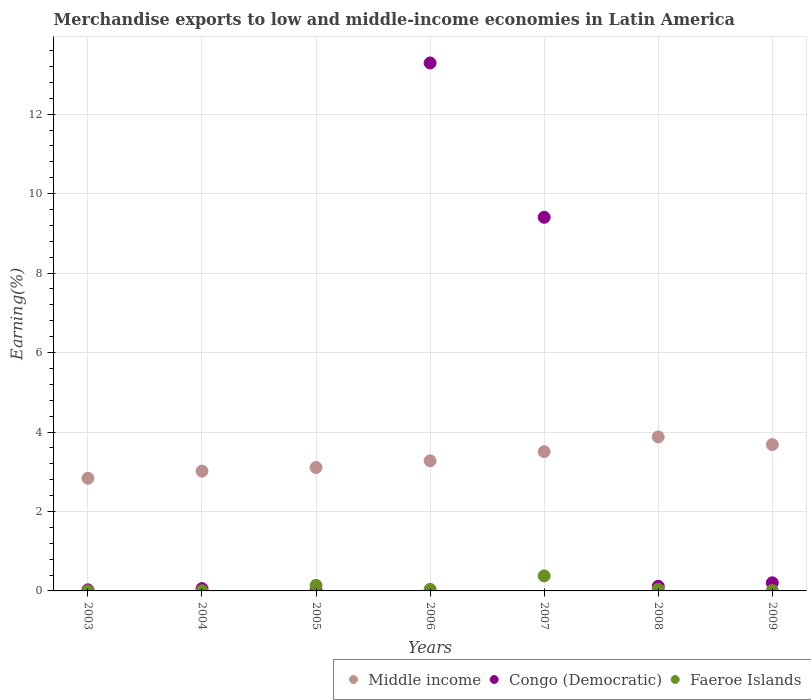How many different coloured dotlines are there?
Your response must be concise. 3. Is the number of dotlines equal to the number of legend labels?
Your answer should be very brief. Yes. What is the percentage of amount earned from merchandise exports in Middle income in 2004?
Provide a short and direct response. 3.02. Across all years, what is the maximum percentage of amount earned from merchandise exports in Middle income?
Provide a short and direct response. 3.88. Across all years, what is the minimum percentage of amount earned from merchandise exports in Congo (Democratic)?
Offer a terse response. 0.02. In which year was the percentage of amount earned from merchandise exports in Congo (Democratic) minimum?
Ensure brevity in your answer.  2005. What is the total percentage of amount earned from merchandise exports in Middle income in the graph?
Your answer should be very brief. 23.3. What is the difference between the percentage of amount earned from merchandise exports in Congo (Democratic) in 2005 and that in 2007?
Ensure brevity in your answer.  -9.39. What is the difference between the percentage of amount earned from merchandise exports in Congo (Democratic) in 2005 and the percentage of amount earned from merchandise exports in Middle income in 2007?
Offer a terse response. -3.49. What is the average percentage of amount earned from merchandise exports in Faeroe Islands per year?
Provide a short and direct response. 0.09. In the year 2004, what is the difference between the percentage of amount earned from merchandise exports in Faeroe Islands and percentage of amount earned from merchandise exports in Middle income?
Give a very brief answer. -3.01. What is the ratio of the percentage of amount earned from merchandise exports in Faeroe Islands in 2005 to that in 2007?
Your answer should be compact. 0.37. What is the difference between the highest and the second highest percentage of amount earned from merchandise exports in Faeroe Islands?
Give a very brief answer. 0.24. What is the difference between the highest and the lowest percentage of amount earned from merchandise exports in Middle income?
Provide a short and direct response. 1.04. In how many years, is the percentage of amount earned from merchandise exports in Middle income greater than the average percentage of amount earned from merchandise exports in Middle income taken over all years?
Offer a very short reply. 3. Is the sum of the percentage of amount earned from merchandise exports in Middle income in 2004 and 2009 greater than the maximum percentage of amount earned from merchandise exports in Congo (Democratic) across all years?
Your answer should be compact. No. Is it the case that in every year, the sum of the percentage of amount earned from merchandise exports in Middle income and percentage of amount earned from merchandise exports in Congo (Democratic)  is greater than the percentage of amount earned from merchandise exports in Faeroe Islands?
Provide a succinct answer. Yes. Is the percentage of amount earned from merchandise exports in Congo (Democratic) strictly less than the percentage of amount earned from merchandise exports in Middle income over the years?
Offer a terse response. No. What is the difference between two consecutive major ticks on the Y-axis?
Give a very brief answer. 2. What is the title of the graph?
Your answer should be compact. Merchandise exports to low and middle-income economies in Latin America. What is the label or title of the Y-axis?
Provide a succinct answer. Earning(%). What is the Earning(%) of Middle income in 2003?
Provide a short and direct response. 2.84. What is the Earning(%) in Congo (Democratic) in 2003?
Provide a short and direct response. 0.03. What is the Earning(%) in Faeroe Islands in 2003?
Make the answer very short. 0. What is the Earning(%) of Middle income in 2004?
Your answer should be compact. 3.02. What is the Earning(%) of Congo (Democratic) in 2004?
Ensure brevity in your answer.  0.06. What is the Earning(%) of Faeroe Islands in 2004?
Give a very brief answer. 0. What is the Earning(%) of Middle income in 2005?
Provide a short and direct response. 3.11. What is the Earning(%) of Congo (Democratic) in 2005?
Ensure brevity in your answer.  0.02. What is the Earning(%) of Faeroe Islands in 2005?
Your answer should be compact. 0.14. What is the Earning(%) in Middle income in 2006?
Give a very brief answer. 3.27. What is the Earning(%) in Congo (Democratic) in 2006?
Make the answer very short. 13.29. What is the Earning(%) of Faeroe Islands in 2006?
Keep it short and to the point. 0.04. What is the Earning(%) of Middle income in 2007?
Offer a terse response. 3.5. What is the Earning(%) of Congo (Democratic) in 2007?
Provide a succinct answer. 9.4. What is the Earning(%) in Faeroe Islands in 2007?
Make the answer very short. 0.38. What is the Earning(%) in Middle income in 2008?
Keep it short and to the point. 3.88. What is the Earning(%) of Congo (Democratic) in 2008?
Your answer should be very brief. 0.12. What is the Earning(%) in Faeroe Islands in 2008?
Provide a short and direct response. 0.04. What is the Earning(%) of Middle income in 2009?
Your answer should be compact. 3.68. What is the Earning(%) in Congo (Democratic) in 2009?
Your answer should be very brief. 0.2. What is the Earning(%) of Faeroe Islands in 2009?
Your response must be concise. 0.01. Across all years, what is the maximum Earning(%) in Middle income?
Provide a short and direct response. 3.88. Across all years, what is the maximum Earning(%) of Congo (Democratic)?
Your response must be concise. 13.29. Across all years, what is the maximum Earning(%) of Faeroe Islands?
Make the answer very short. 0.38. Across all years, what is the minimum Earning(%) in Middle income?
Ensure brevity in your answer.  2.84. Across all years, what is the minimum Earning(%) of Congo (Democratic)?
Keep it short and to the point. 0.02. Across all years, what is the minimum Earning(%) in Faeroe Islands?
Your answer should be very brief. 0. What is the total Earning(%) in Middle income in the graph?
Your response must be concise. 23.3. What is the total Earning(%) in Congo (Democratic) in the graph?
Provide a short and direct response. 23.12. What is the total Earning(%) of Faeroe Islands in the graph?
Give a very brief answer. 0.62. What is the difference between the Earning(%) of Middle income in 2003 and that in 2004?
Make the answer very short. -0.18. What is the difference between the Earning(%) in Congo (Democratic) in 2003 and that in 2004?
Offer a terse response. -0.03. What is the difference between the Earning(%) of Faeroe Islands in 2003 and that in 2004?
Offer a terse response. -0. What is the difference between the Earning(%) in Middle income in 2003 and that in 2005?
Provide a succinct answer. -0.27. What is the difference between the Earning(%) of Congo (Democratic) in 2003 and that in 2005?
Offer a very short reply. 0.01. What is the difference between the Earning(%) in Faeroe Islands in 2003 and that in 2005?
Ensure brevity in your answer.  -0.14. What is the difference between the Earning(%) in Middle income in 2003 and that in 2006?
Provide a short and direct response. -0.44. What is the difference between the Earning(%) of Congo (Democratic) in 2003 and that in 2006?
Keep it short and to the point. -13.26. What is the difference between the Earning(%) of Faeroe Islands in 2003 and that in 2006?
Your answer should be compact. -0.03. What is the difference between the Earning(%) in Middle income in 2003 and that in 2007?
Provide a succinct answer. -0.67. What is the difference between the Earning(%) of Congo (Democratic) in 2003 and that in 2007?
Your answer should be very brief. -9.38. What is the difference between the Earning(%) of Faeroe Islands in 2003 and that in 2007?
Your response must be concise. -0.38. What is the difference between the Earning(%) of Middle income in 2003 and that in 2008?
Make the answer very short. -1.04. What is the difference between the Earning(%) of Congo (Democratic) in 2003 and that in 2008?
Keep it short and to the point. -0.09. What is the difference between the Earning(%) of Faeroe Islands in 2003 and that in 2008?
Provide a succinct answer. -0.04. What is the difference between the Earning(%) in Middle income in 2003 and that in 2009?
Make the answer very short. -0.85. What is the difference between the Earning(%) in Congo (Democratic) in 2003 and that in 2009?
Offer a very short reply. -0.18. What is the difference between the Earning(%) in Faeroe Islands in 2003 and that in 2009?
Offer a very short reply. -0.01. What is the difference between the Earning(%) of Middle income in 2004 and that in 2005?
Keep it short and to the point. -0.09. What is the difference between the Earning(%) of Congo (Democratic) in 2004 and that in 2005?
Provide a short and direct response. 0.04. What is the difference between the Earning(%) of Faeroe Islands in 2004 and that in 2005?
Offer a terse response. -0.14. What is the difference between the Earning(%) of Middle income in 2004 and that in 2006?
Your answer should be compact. -0.26. What is the difference between the Earning(%) in Congo (Democratic) in 2004 and that in 2006?
Make the answer very short. -13.23. What is the difference between the Earning(%) of Faeroe Islands in 2004 and that in 2006?
Give a very brief answer. -0.03. What is the difference between the Earning(%) of Middle income in 2004 and that in 2007?
Your answer should be very brief. -0.49. What is the difference between the Earning(%) of Congo (Democratic) in 2004 and that in 2007?
Keep it short and to the point. -9.35. What is the difference between the Earning(%) in Faeroe Islands in 2004 and that in 2007?
Keep it short and to the point. -0.37. What is the difference between the Earning(%) in Middle income in 2004 and that in 2008?
Make the answer very short. -0.86. What is the difference between the Earning(%) of Congo (Democratic) in 2004 and that in 2008?
Give a very brief answer. -0.06. What is the difference between the Earning(%) in Faeroe Islands in 2004 and that in 2008?
Keep it short and to the point. -0.04. What is the difference between the Earning(%) of Middle income in 2004 and that in 2009?
Your response must be concise. -0.67. What is the difference between the Earning(%) of Congo (Democratic) in 2004 and that in 2009?
Make the answer very short. -0.15. What is the difference between the Earning(%) of Faeroe Islands in 2004 and that in 2009?
Make the answer very short. -0.01. What is the difference between the Earning(%) in Middle income in 2005 and that in 2006?
Your answer should be compact. -0.17. What is the difference between the Earning(%) in Congo (Democratic) in 2005 and that in 2006?
Provide a succinct answer. -13.27. What is the difference between the Earning(%) in Faeroe Islands in 2005 and that in 2006?
Your answer should be compact. 0.1. What is the difference between the Earning(%) in Middle income in 2005 and that in 2007?
Offer a terse response. -0.4. What is the difference between the Earning(%) of Congo (Democratic) in 2005 and that in 2007?
Offer a very short reply. -9.39. What is the difference between the Earning(%) in Faeroe Islands in 2005 and that in 2007?
Give a very brief answer. -0.24. What is the difference between the Earning(%) in Middle income in 2005 and that in 2008?
Ensure brevity in your answer.  -0.77. What is the difference between the Earning(%) in Congo (Democratic) in 2005 and that in 2008?
Offer a very short reply. -0.1. What is the difference between the Earning(%) in Faeroe Islands in 2005 and that in 2008?
Offer a terse response. 0.1. What is the difference between the Earning(%) in Middle income in 2005 and that in 2009?
Your response must be concise. -0.58. What is the difference between the Earning(%) in Congo (Democratic) in 2005 and that in 2009?
Ensure brevity in your answer.  -0.19. What is the difference between the Earning(%) in Faeroe Islands in 2005 and that in 2009?
Provide a succinct answer. 0.13. What is the difference between the Earning(%) in Middle income in 2006 and that in 2007?
Provide a succinct answer. -0.23. What is the difference between the Earning(%) in Congo (Democratic) in 2006 and that in 2007?
Make the answer very short. 3.88. What is the difference between the Earning(%) in Faeroe Islands in 2006 and that in 2007?
Offer a terse response. -0.34. What is the difference between the Earning(%) of Middle income in 2006 and that in 2008?
Provide a succinct answer. -0.6. What is the difference between the Earning(%) of Congo (Democratic) in 2006 and that in 2008?
Offer a terse response. 13.17. What is the difference between the Earning(%) of Faeroe Islands in 2006 and that in 2008?
Offer a terse response. -0. What is the difference between the Earning(%) in Middle income in 2006 and that in 2009?
Provide a short and direct response. -0.41. What is the difference between the Earning(%) in Congo (Democratic) in 2006 and that in 2009?
Keep it short and to the point. 13.08. What is the difference between the Earning(%) in Faeroe Islands in 2006 and that in 2009?
Ensure brevity in your answer.  0.03. What is the difference between the Earning(%) in Middle income in 2007 and that in 2008?
Offer a terse response. -0.37. What is the difference between the Earning(%) of Congo (Democratic) in 2007 and that in 2008?
Ensure brevity in your answer.  9.29. What is the difference between the Earning(%) of Faeroe Islands in 2007 and that in 2008?
Your answer should be very brief. 0.34. What is the difference between the Earning(%) in Middle income in 2007 and that in 2009?
Offer a terse response. -0.18. What is the difference between the Earning(%) in Congo (Democratic) in 2007 and that in 2009?
Offer a terse response. 9.2. What is the difference between the Earning(%) of Faeroe Islands in 2007 and that in 2009?
Your response must be concise. 0.37. What is the difference between the Earning(%) in Middle income in 2008 and that in 2009?
Give a very brief answer. 0.19. What is the difference between the Earning(%) of Congo (Democratic) in 2008 and that in 2009?
Offer a very short reply. -0.09. What is the difference between the Earning(%) of Faeroe Islands in 2008 and that in 2009?
Offer a very short reply. 0.03. What is the difference between the Earning(%) in Middle income in 2003 and the Earning(%) in Congo (Democratic) in 2004?
Ensure brevity in your answer.  2.78. What is the difference between the Earning(%) of Middle income in 2003 and the Earning(%) of Faeroe Islands in 2004?
Offer a very short reply. 2.83. What is the difference between the Earning(%) of Congo (Democratic) in 2003 and the Earning(%) of Faeroe Islands in 2004?
Offer a very short reply. 0.02. What is the difference between the Earning(%) of Middle income in 2003 and the Earning(%) of Congo (Democratic) in 2005?
Keep it short and to the point. 2.82. What is the difference between the Earning(%) in Middle income in 2003 and the Earning(%) in Faeroe Islands in 2005?
Make the answer very short. 2.7. What is the difference between the Earning(%) in Congo (Democratic) in 2003 and the Earning(%) in Faeroe Islands in 2005?
Your answer should be compact. -0.11. What is the difference between the Earning(%) of Middle income in 2003 and the Earning(%) of Congo (Democratic) in 2006?
Your response must be concise. -10.45. What is the difference between the Earning(%) of Middle income in 2003 and the Earning(%) of Faeroe Islands in 2006?
Offer a very short reply. 2.8. What is the difference between the Earning(%) of Congo (Democratic) in 2003 and the Earning(%) of Faeroe Islands in 2006?
Make the answer very short. -0.01. What is the difference between the Earning(%) of Middle income in 2003 and the Earning(%) of Congo (Democratic) in 2007?
Your answer should be compact. -6.57. What is the difference between the Earning(%) of Middle income in 2003 and the Earning(%) of Faeroe Islands in 2007?
Your answer should be compact. 2.46. What is the difference between the Earning(%) of Congo (Democratic) in 2003 and the Earning(%) of Faeroe Islands in 2007?
Provide a succinct answer. -0.35. What is the difference between the Earning(%) of Middle income in 2003 and the Earning(%) of Congo (Democratic) in 2008?
Make the answer very short. 2.72. What is the difference between the Earning(%) of Middle income in 2003 and the Earning(%) of Faeroe Islands in 2008?
Provide a succinct answer. 2.79. What is the difference between the Earning(%) in Congo (Democratic) in 2003 and the Earning(%) in Faeroe Islands in 2008?
Your response must be concise. -0.02. What is the difference between the Earning(%) in Middle income in 2003 and the Earning(%) in Congo (Democratic) in 2009?
Offer a terse response. 2.63. What is the difference between the Earning(%) of Middle income in 2003 and the Earning(%) of Faeroe Islands in 2009?
Provide a short and direct response. 2.83. What is the difference between the Earning(%) of Congo (Democratic) in 2003 and the Earning(%) of Faeroe Islands in 2009?
Offer a very short reply. 0.02. What is the difference between the Earning(%) in Middle income in 2004 and the Earning(%) in Congo (Democratic) in 2005?
Offer a terse response. 3. What is the difference between the Earning(%) of Middle income in 2004 and the Earning(%) of Faeroe Islands in 2005?
Provide a succinct answer. 2.88. What is the difference between the Earning(%) of Congo (Democratic) in 2004 and the Earning(%) of Faeroe Islands in 2005?
Offer a terse response. -0.08. What is the difference between the Earning(%) of Middle income in 2004 and the Earning(%) of Congo (Democratic) in 2006?
Your response must be concise. -10.27. What is the difference between the Earning(%) in Middle income in 2004 and the Earning(%) in Faeroe Islands in 2006?
Offer a terse response. 2.98. What is the difference between the Earning(%) of Congo (Democratic) in 2004 and the Earning(%) of Faeroe Islands in 2006?
Offer a very short reply. 0.02. What is the difference between the Earning(%) in Middle income in 2004 and the Earning(%) in Congo (Democratic) in 2007?
Give a very brief answer. -6.39. What is the difference between the Earning(%) in Middle income in 2004 and the Earning(%) in Faeroe Islands in 2007?
Keep it short and to the point. 2.64. What is the difference between the Earning(%) in Congo (Democratic) in 2004 and the Earning(%) in Faeroe Islands in 2007?
Keep it short and to the point. -0.32. What is the difference between the Earning(%) in Middle income in 2004 and the Earning(%) in Congo (Democratic) in 2008?
Provide a succinct answer. 2.9. What is the difference between the Earning(%) of Middle income in 2004 and the Earning(%) of Faeroe Islands in 2008?
Offer a terse response. 2.97. What is the difference between the Earning(%) in Congo (Democratic) in 2004 and the Earning(%) in Faeroe Islands in 2008?
Give a very brief answer. 0.02. What is the difference between the Earning(%) in Middle income in 2004 and the Earning(%) in Congo (Democratic) in 2009?
Provide a succinct answer. 2.81. What is the difference between the Earning(%) in Middle income in 2004 and the Earning(%) in Faeroe Islands in 2009?
Your answer should be compact. 3. What is the difference between the Earning(%) of Congo (Democratic) in 2004 and the Earning(%) of Faeroe Islands in 2009?
Your answer should be very brief. 0.05. What is the difference between the Earning(%) in Middle income in 2005 and the Earning(%) in Congo (Democratic) in 2006?
Give a very brief answer. -10.18. What is the difference between the Earning(%) in Middle income in 2005 and the Earning(%) in Faeroe Islands in 2006?
Give a very brief answer. 3.07. What is the difference between the Earning(%) in Congo (Democratic) in 2005 and the Earning(%) in Faeroe Islands in 2006?
Keep it short and to the point. -0.02. What is the difference between the Earning(%) in Middle income in 2005 and the Earning(%) in Congo (Democratic) in 2007?
Your response must be concise. -6.3. What is the difference between the Earning(%) of Middle income in 2005 and the Earning(%) of Faeroe Islands in 2007?
Offer a very short reply. 2.73. What is the difference between the Earning(%) of Congo (Democratic) in 2005 and the Earning(%) of Faeroe Islands in 2007?
Your answer should be very brief. -0.36. What is the difference between the Earning(%) in Middle income in 2005 and the Earning(%) in Congo (Democratic) in 2008?
Offer a terse response. 2.99. What is the difference between the Earning(%) in Middle income in 2005 and the Earning(%) in Faeroe Islands in 2008?
Your response must be concise. 3.06. What is the difference between the Earning(%) in Congo (Democratic) in 2005 and the Earning(%) in Faeroe Islands in 2008?
Make the answer very short. -0.03. What is the difference between the Earning(%) in Middle income in 2005 and the Earning(%) in Congo (Democratic) in 2009?
Make the answer very short. 2.9. What is the difference between the Earning(%) in Middle income in 2005 and the Earning(%) in Faeroe Islands in 2009?
Offer a very short reply. 3.09. What is the difference between the Earning(%) in Congo (Democratic) in 2005 and the Earning(%) in Faeroe Islands in 2009?
Offer a terse response. 0.01. What is the difference between the Earning(%) of Middle income in 2006 and the Earning(%) of Congo (Democratic) in 2007?
Provide a short and direct response. -6.13. What is the difference between the Earning(%) in Middle income in 2006 and the Earning(%) in Faeroe Islands in 2007?
Your response must be concise. 2.9. What is the difference between the Earning(%) in Congo (Democratic) in 2006 and the Earning(%) in Faeroe Islands in 2007?
Offer a very short reply. 12.91. What is the difference between the Earning(%) of Middle income in 2006 and the Earning(%) of Congo (Democratic) in 2008?
Make the answer very short. 3.16. What is the difference between the Earning(%) in Middle income in 2006 and the Earning(%) in Faeroe Islands in 2008?
Make the answer very short. 3.23. What is the difference between the Earning(%) of Congo (Democratic) in 2006 and the Earning(%) of Faeroe Islands in 2008?
Offer a terse response. 13.25. What is the difference between the Earning(%) of Middle income in 2006 and the Earning(%) of Congo (Democratic) in 2009?
Your answer should be compact. 3.07. What is the difference between the Earning(%) of Middle income in 2006 and the Earning(%) of Faeroe Islands in 2009?
Your response must be concise. 3.26. What is the difference between the Earning(%) in Congo (Democratic) in 2006 and the Earning(%) in Faeroe Islands in 2009?
Your answer should be compact. 13.28. What is the difference between the Earning(%) of Middle income in 2007 and the Earning(%) of Congo (Democratic) in 2008?
Provide a succinct answer. 3.39. What is the difference between the Earning(%) in Middle income in 2007 and the Earning(%) in Faeroe Islands in 2008?
Offer a very short reply. 3.46. What is the difference between the Earning(%) of Congo (Democratic) in 2007 and the Earning(%) of Faeroe Islands in 2008?
Make the answer very short. 9.36. What is the difference between the Earning(%) of Middle income in 2007 and the Earning(%) of Congo (Democratic) in 2009?
Provide a succinct answer. 3.3. What is the difference between the Earning(%) in Middle income in 2007 and the Earning(%) in Faeroe Islands in 2009?
Your answer should be very brief. 3.49. What is the difference between the Earning(%) of Congo (Democratic) in 2007 and the Earning(%) of Faeroe Islands in 2009?
Provide a succinct answer. 9.39. What is the difference between the Earning(%) in Middle income in 2008 and the Earning(%) in Congo (Democratic) in 2009?
Offer a terse response. 3.67. What is the difference between the Earning(%) of Middle income in 2008 and the Earning(%) of Faeroe Islands in 2009?
Give a very brief answer. 3.87. What is the difference between the Earning(%) in Congo (Democratic) in 2008 and the Earning(%) in Faeroe Islands in 2009?
Your answer should be compact. 0.11. What is the average Earning(%) of Middle income per year?
Offer a very short reply. 3.33. What is the average Earning(%) of Congo (Democratic) per year?
Make the answer very short. 3.3. What is the average Earning(%) in Faeroe Islands per year?
Give a very brief answer. 0.09. In the year 2003, what is the difference between the Earning(%) in Middle income and Earning(%) in Congo (Democratic)?
Your response must be concise. 2.81. In the year 2003, what is the difference between the Earning(%) of Middle income and Earning(%) of Faeroe Islands?
Provide a succinct answer. 2.83. In the year 2003, what is the difference between the Earning(%) of Congo (Democratic) and Earning(%) of Faeroe Islands?
Ensure brevity in your answer.  0.02. In the year 2004, what is the difference between the Earning(%) of Middle income and Earning(%) of Congo (Democratic)?
Your answer should be compact. 2.96. In the year 2004, what is the difference between the Earning(%) of Middle income and Earning(%) of Faeroe Islands?
Make the answer very short. 3.01. In the year 2004, what is the difference between the Earning(%) of Congo (Democratic) and Earning(%) of Faeroe Islands?
Keep it short and to the point. 0.05. In the year 2005, what is the difference between the Earning(%) of Middle income and Earning(%) of Congo (Democratic)?
Provide a short and direct response. 3.09. In the year 2005, what is the difference between the Earning(%) in Middle income and Earning(%) in Faeroe Islands?
Offer a very short reply. 2.97. In the year 2005, what is the difference between the Earning(%) in Congo (Democratic) and Earning(%) in Faeroe Islands?
Provide a succinct answer. -0.12. In the year 2006, what is the difference between the Earning(%) in Middle income and Earning(%) in Congo (Democratic)?
Make the answer very short. -10.01. In the year 2006, what is the difference between the Earning(%) in Middle income and Earning(%) in Faeroe Islands?
Provide a succinct answer. 3.24. In the year 2006, what is the difference between the Earning(%) in Congo (Democratic) and Earning(%) in Faeroe Islands?
Provide a short and direct response. 13.25. In the year 2007, what is the difference between the Earning(%) of Middle income and Earning(%) of Faeroe Islands?
Your answer should be very brief. 3.13. In the year 2007, what is the difference between the Earning(%) in Congo (Democratic) and Earning(%) in Faeroe Islands?
Provide a short and direct response. 9.03. In the year 2008, what is the difference between the Earning(%) in Middle income and Earning(%) in Congo (Democratic)?
Provide a succinct answer. 3.76. In the year 2008, what is the difference between the Earning(%) of Middle income and Earning(%) of Faeroe Islands?
Provide a succinct answer. 3.83. In the year 2008, what is the difference between the Earning(%) in Congo (Democratic) and Earning(%) in Faeroe Islands?
Offer a very short reply. 0.07. In the year 2009, what is the difference between the Earning(%) of Middle income and Earning(%) of Congo (Democratic)?
Provide a short and direct response. 3.48. In the year 2009, what is the difference between the Earning(%) of Middle income and Earning(%) of Faeroe Islands?
Your answer should be very brief. 3.67. In the year 2009, what is the difference between the Earning(%) in Congo (Democratic) and Earning(%) in Faeroe Islands?
Your answer should be very brief. 0.19. What is the ratio of the Earning(%) of Middle income in 2003 to that in 2004?
Offer a terse response. 0.94. What is the ratio of the Earning(%) of Congo (Democratic) in 2003 to that in 2004?
Your answer should be very brief. 0.47. What is the ratio of the Earning(%) in Faeroe Islands in 2003 to that in 2004?
Offer a very short reply. 0.9. What is the ratio of the Earning(%) of Middle income in 2003 to that in 2005?
Your response must be concise. 0.91. What is the ratio of the Earning(%) in Congo (Democratic) in 2003 to that in 2005?
Keep it short and to the point. 1.68. What is the ratio of the Earning(%) of Faeroe Islands in 2003 to that in 2005?
Offer a terse response. 0.03. What is the ratio of the Earning(%) of Middle income in 2003 to that in 2006?
Give a very brief answer. 0.87. What is the ratio of the Earning(%) of Congo (Democratic) in 2003 to that in 2006?
Provide a succinct answer. 0. What is the ratio of the Earning(%) in Faeroe Islands in 2003 to that in 2006?
Provide a short and direct response. 0.1. What is the ratio of the Earning(%) of Middle income in 2003 to that in 2007?
Keep it short and to the point. 0.81. What is the ratio of the Earning(%) of Congo (Democratic) in 2003 to that in 2007?
Give a very brief answer. 0. What is the ratio of the Earning(%) of Faeroe Islands in 2003 to that in 2007?
Provide a short and direct response. 0.01. What is the ratio of the Earning(%) of Middle income in 2003 to that in 2008?
Give a very brief answer. 0.73. What is the ratio of the Earning(%) of Congo (Democratic) in 2003 to that in 2008?
Provide a short and direct response. 0.23. What is the ratio of the Earning(%) of Faeroe Islands in 2003 to that in 2008?
Offer a very short reply. 0.09. What is the ratio of the Earning(%) of Middle income in 2003 to that in 2009?
Provide a short and direct response. 0.77. What is the ratio of the Earning(%) in Congo (Democratic) in 2003 to that in 2009?
Your answer should be compact. 0.13. What is the ratio of the Earning(%) of Faeroe Islands in 2003 to that in 2009?
Provide a succinct answer. 0.35. What is the ratio of the Earning(%) in Congo (Democratic) in 2004 to that in 2005?
Your response must be concise. 3.59. What is the ratio of the Earning(%) in Faeroe Islands in 2004 to that in 2005?
Offer a very short reply. 0.03. What is the ratio of the Earning(%) in Middle income in 2004 to that in 2006?
Your response must be concise. 0.92. What is the ratio of the Earning(%) of Congo (Democratic) in 2004 to that in 2006?
Your response must be concise. 0. What is the ratio of the Earning(%) in Faeroe Islands in 2004 to that in 2006?
Ensure brevity in your answer.  0.11. What is the ratio of the Earning(%) in Middle income in 2004 to that in 2007?
Your response must be concise. 0.86. What is the ratio of the Earning(%) in Congo (Democratic) in 2004 to that in 2007?
Make the answer very short. 0.01. What is the ratio of the Earning(%) in Faeroe Islands in 2004 to that in 2007?
Your answer should be compact. 0.01. What is the ratio of the Earning(%) of Middle income in 2004 to that in 2008?
Keep it short and to the point. 0.78. What is the ratio of the Earning(%) of Congo (Democratic) in 2004 to that in 2008?
Offer a very short reply. 0.5. What is the ratio of the Earning(%) of Faeroe Islands in 2004 to that in 2008?
Offer a terse response. 0.1. What is the ratio of the Earning(%) of Middle income in 2004 to that in 2009?
Your answer should be compact. 0.82. What is the ratio of the Earning(%) of Congo (Democratic) in 2004 to that in 2009?
Offer a very short reply. 0.28. What is the ratio of the Earning(%) in Faeroe Islands in 2004 to that in 2009?
Give a very brief answer. 0.38. What is the ratio of the Earning(%) of Middle income in 2005 to that in 2006?
Offer a very short reply. 0.95. What is the ratio of the Earning(%) of Congo (Democratic) in 2005 to that in 2006?
Provide a short and direct response. 0. What is the ratio of the Earning(%) in Faeroe Islands in 2005 to that in 2006?
Your answer should be compact. 3.65. What is the ratio of the Earning(%) of Middle income in 2005 to that in 2007?
Your answer should be compact. 0.89. What is the ratio of the Earning(%) of Congo (Democratic) in 2005 to that in 2007?
Make the answer very short. 0. What is the ratio of the Earning(%) of Faeroe Islands in 2005 to that in 2007?
Offer a very short reply. 0.37. What is the ratio of the Earning(%) in Middle income in 2005 to that in 2008?
Make the answer very short. 0.8. What is the ratio of the Earning(%) in Congo (Democratic) in 2005 to that in 2008?
Ensure brevity in your answer.  0.14. What is the ratio of the Earning(%) in Faeroe Islands in 2005 to that in 2008?
Offer a very short reply. 3.26. What is the ratio of the Earning(%) in Middle income in 2005 to that in 2009?
Make the answer very short. 0.84. What is the ratio of the Earning(%) in Congo (Democratic) in 2005 to that in 2009?
Make the answer very short. 0.08. What is the ratio of the Earning(%) in Faeroe Islands in 2005 to that in 2009?
Offer a terse response. 12.86. What is the ratio of the Earning(%) in Middle income in 2006 to that in 2007?
Your response must be concise. 0.93. What is the ratio of the Earning(%) in Congo (Democratic) in 2006 to that in 2007?
Offer a terse response. 1.41. What is the ratio of the Earning(%) of Faeroe Islands in 2006 to that in 2007?
Make the answer very short. 0.1. What is the ratio of the Earning(%) of Middle income in 2006 to that in 2008?
Provide a short and direct response. 0.84. What is the ratio of the Earning(%) in Congo (Democratic) in 2006 to that in 2008?
Offer a very short reply. 114.37. What is the ratio of the Earning(%) of Faeroe Islands in 2006 to that in 2008?
Keep it short and to the point. 0.89. What is the ratio of the Earning(%) in Middle income in 2006 to that in 2009?
Your response must be concise. 0.89. What is the ratio of the Earning(%) in Congo (Democratic) in 2006 to that in 2009?
Your response must be concise. 65.02. What is the ratio of the Earning(%) of Faeroe Islands in 2006 to that in 2009?
Your response must be concise. 3.52. What is the ratio of the Earning(%) in Middle income in 2007 to that in 2008?
Your answer should be compact. 0.9. What is the ratio of the Earning(%) of Congo (Democratic) in 2007 to that in 2008?
Your answer should be compact. 80.94. What is the ratio of the Earning(%) in Faeroe Islands in 2007 to that in 2008?
Make the answer very short. 8.86. What is the ratio of the Earning(%) of Middle income in 2007 to that in 2009?
Your answer should be very brief. 0.95. What is the ratio of the Earning(%) in Congo (Democratic) in 2007 to that in 2009?
Provide a short and direct response. 46.02. What is the ratio of the Earning(%) of Faeroe Islands in 2007 to that in 2009?
Make the answer very short. 34.95. What is the ratio of the Earning(%) in Middle income in 2008 to that in 2009?
Provide a short and direct response. 1.05. What is the ratio of the Earning(%) of Congo (Democratic) in 2008 to that in 2009?
Offer a terse response. 0.57. What is the ratio of the Earning(%) of Faeroe Islands in 2008 to that in 2009?
Provide a succinct answer. 3.94. What is the difference between the highest and the second highest Earning(%) of Middle income?
Make the answer very short. 0.19. What is the difference between the highest and the second highest Earning(%) in Congo (Democratic)?
Offer a very short reply. 3.88. What is the difference between the highest and the second highest Earning(%) in Faeroe Islands?
Your answer should be very brief. 0.24. What is the difference between the highest and the lowest Earning(%) of Middle income?
Your response must be concise. 1.04. What is the difference between the highest and the lowest Earning(%) in Congo (Democratic)?
Provide a short and direct response. 13.27. What is the difference between the highest and the lowest Earning(%) of Faeroe Islands?
Offer a terse response. 0.38. 